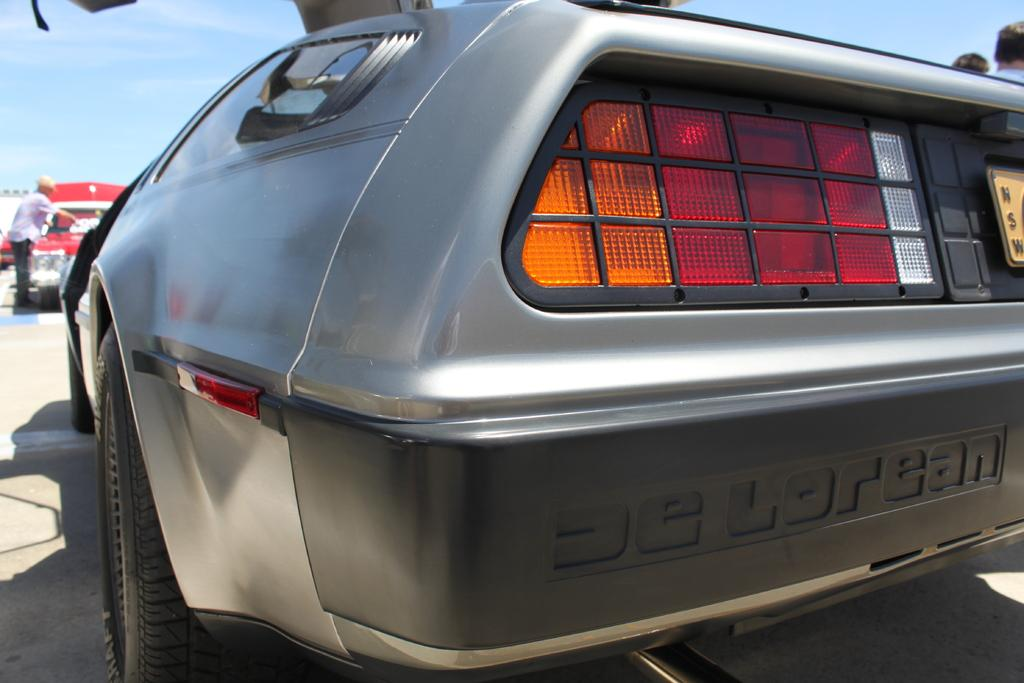What is the main subject in the foreground of the image? There is a car in the foreground of the image. What else can be seen on the left side of the image? There are cars and a person on the left side of the image. What is visible at the top of the image? The sky is visible at the top of the image. Can you see any part of a person on the right side of the image? Yes, a person's head is visible on the right side of the image. What type of yarn is being used to create the coastline in the image? There is no yarn or coastline present in the image; it features a car in the foreground and other subjects and objects as described in the conversation. 